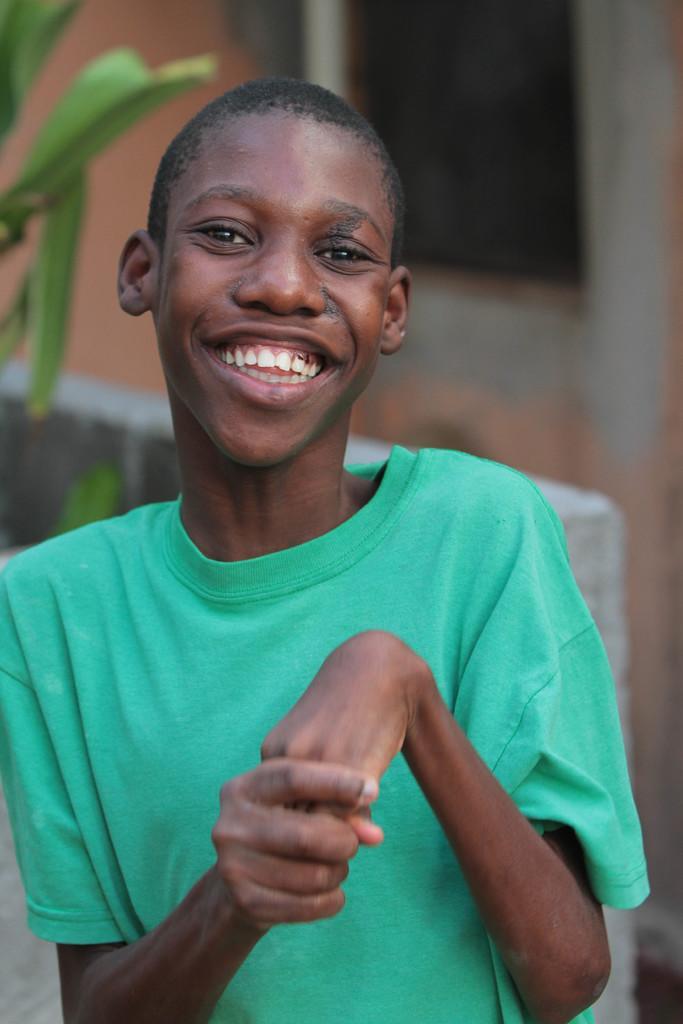Can you describe this image briefly? In this image we can see a boy. In the back there are leaves. And it is blurry in the background. Also there is a wall. 